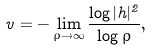<formula> <loc_0><loc_0><loc_500><loc_500>v = - \lim _ { \rho \rightarrow \infty } \frac { \log | h | ^ { 2 } } { \log \rho } ,</formula> 